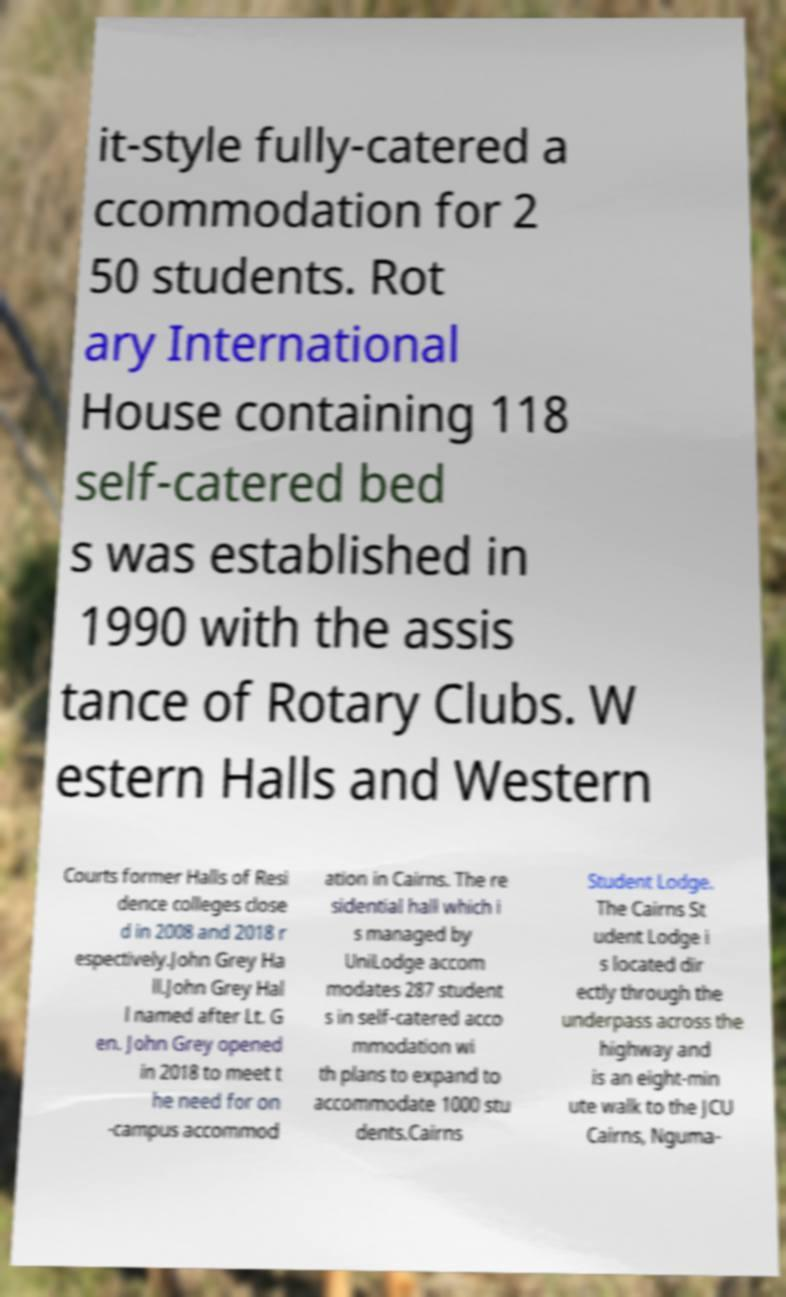There's text embedded in this image that I need extracted. Can you transcribe it verbatim? it-style fully-catered a ccommodation for 2 50 students. Rot ary International House containing 118 self-catered bed s was established in 1990 with the assis tance of Rotary Clubs. W estern Halls and Western Courts former Halls of Resi dence colleges close d in 2008 and 2018 r espectively.John Grey Ha ll.John Grey Hal l named after Lt. G en. John Grey opened in 2018 to meet t he need for on -campus accommod ation in Cairns. The re sidential hall which i s managed by UniLodge accom modates 287 student s in self-catered acco mmodation wi th plans to expand to accommodate 1000 stu dents.Cairns Student Lodge. The Cairns St udent Lodge i s located dir ectly through the underpass across the highway and is an eight-min ute walk to the JCU Cairns, Nguma- 